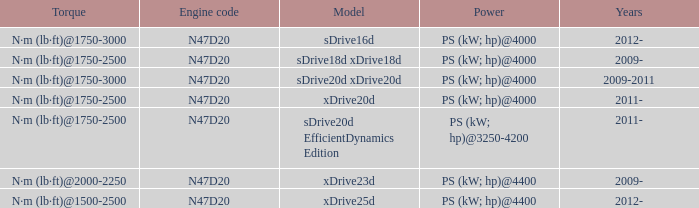What years did the sdrive16d model have a Torque of n·m (lb·ft)@1750-3000? 2012-. 